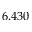Convert formula to latex. <formula><loc_0><loc_0><loc_500><loc_500>6 . 4 3 0</formula> 